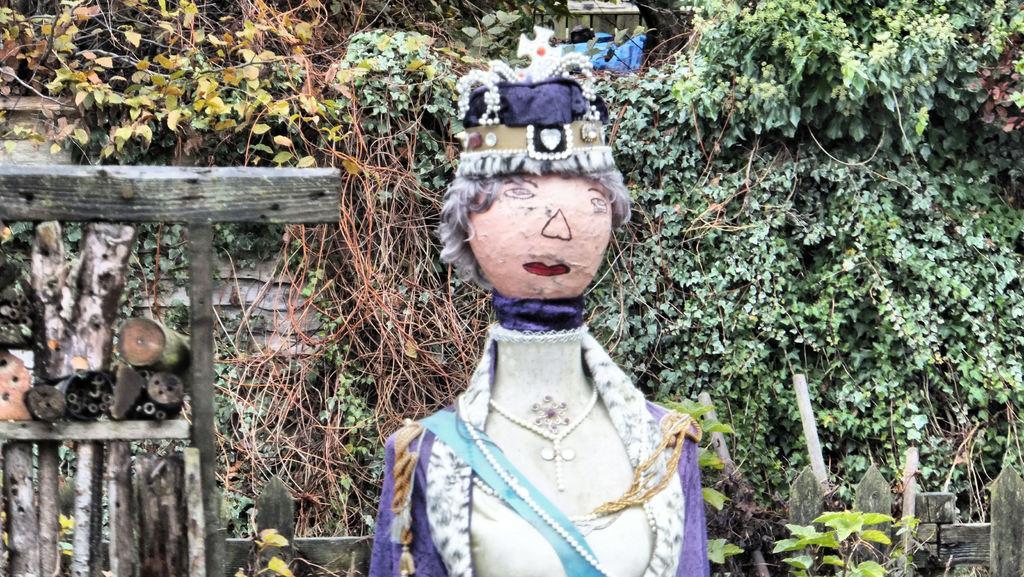Describe this image in one or two sentences. In this picture we can see scarecrow. In the background of the image we can see plants and wooden objects. 